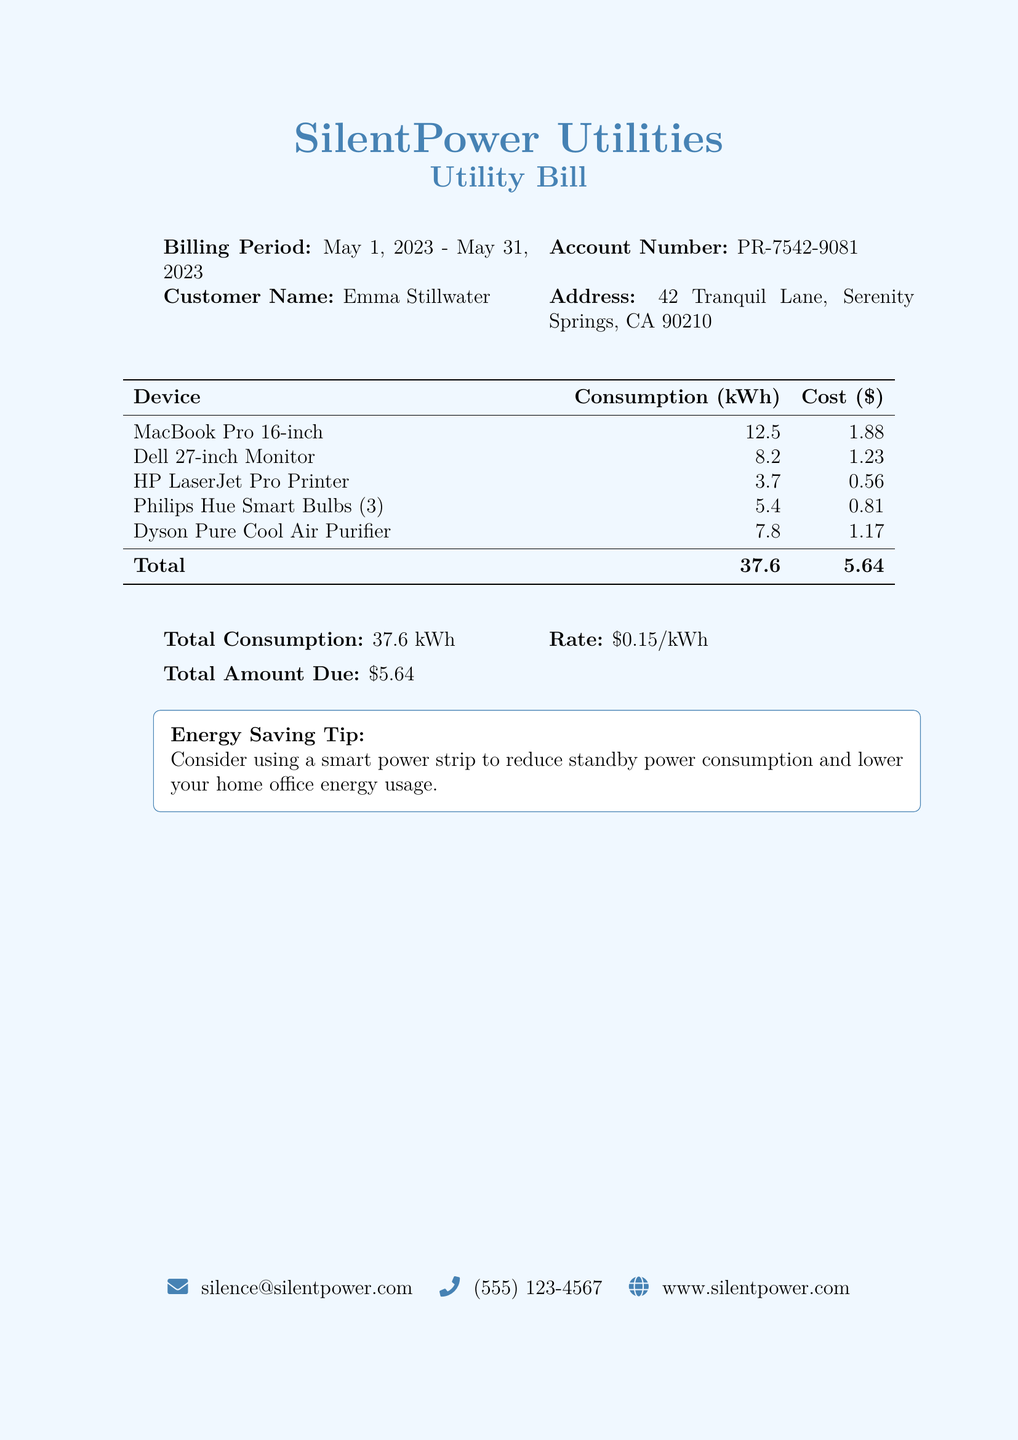What is the billing period? The billing period is specified at the top of the bill as the time frame for which the bill applies.
Answer: May 1, 2023 - May 31, 2023 What is the account number? The account number is a unique identifier for the customer's account mentioned in the document.
Answer: PR-7542-9081 How much did the Philips Hue Smart Bulbs consume in kWh? The consumption of the Philip Hue Smart Bulbs is specifically listed in the table under the 'Consumption (kWh)' column.
Answer: 5.4 What is the total amount due? The total amount due is provided in a summary section at the bottom of the bill, indicating how much the customer needs to pay.
Answer: $5.64 What is the rate per kWh? The rate per kWh is indicated in the summary section of the bill, which shows the cost of electricity usage.
Answer: $0.15/kWh What is the total consumption of electricity? The total consumption is calculated as the sum of all individual device consumptions, as shown in the summary section.
Answer: 37.6 kWh What is the cost associated with the Dell 27-inch Monitor? The cost associated with the Dell 27-inch Monitor can be directly found in the cost column of the consumption table.
Answer: $1.23 What energy-saving tip is provided in the document? The energy-saving tip is included at the bottom of the document, aimed at helping customers reduce energy usage.
Answer: Consider using a smart power strip to reduce standby power consumption 